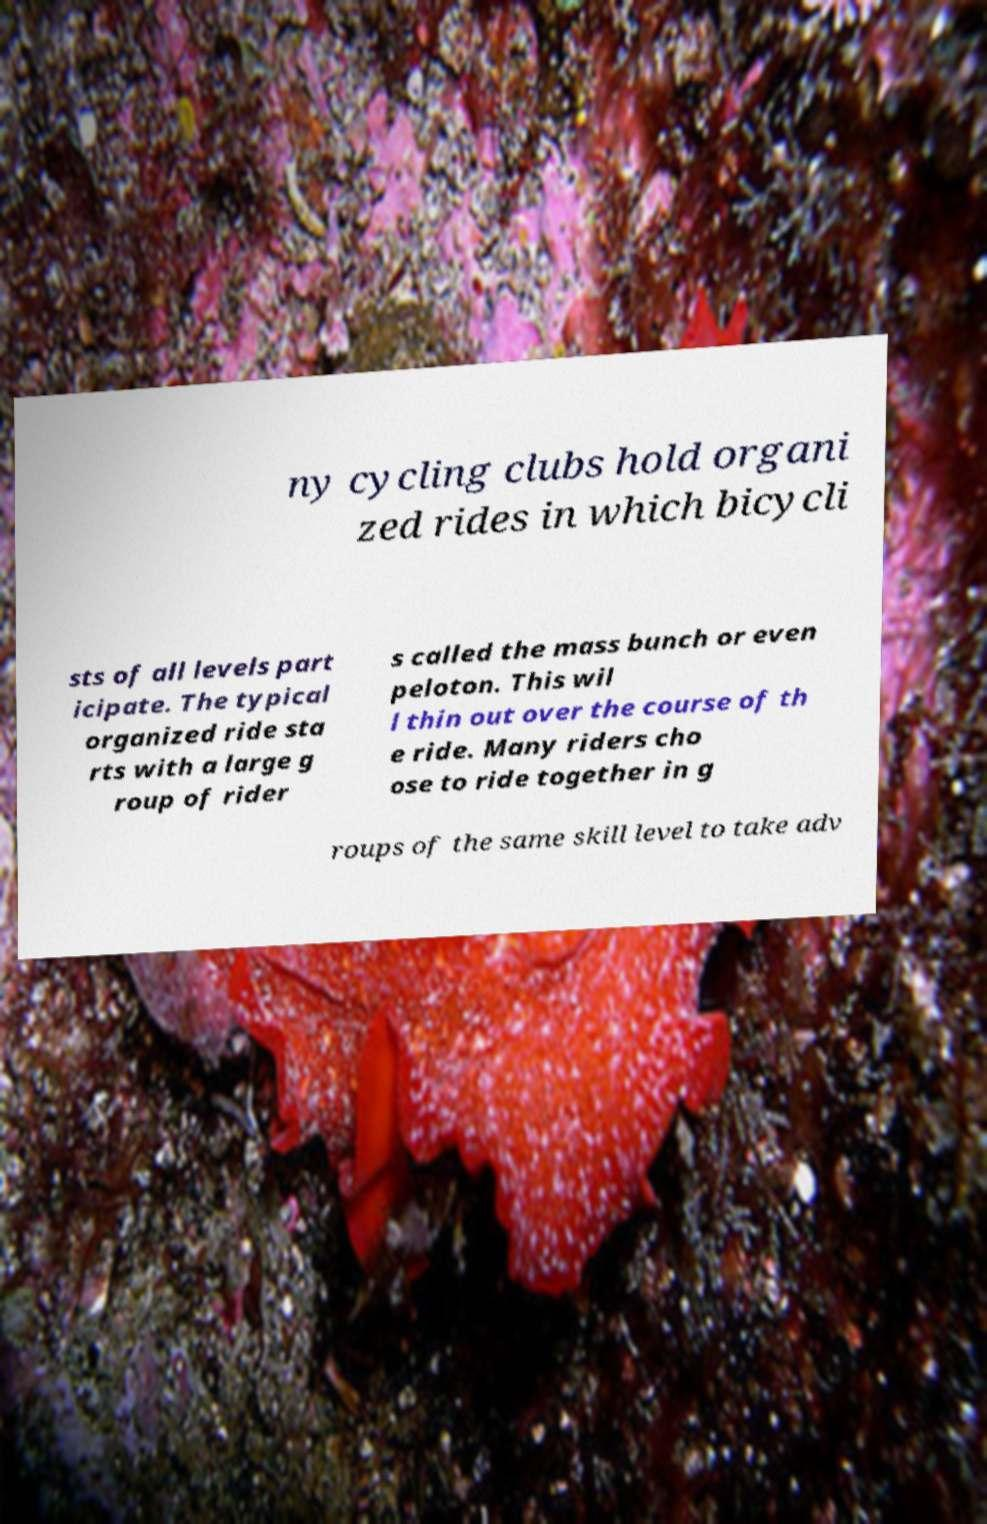What messages or text are displayed in this image? I need them in a readable, typed format. ny cycling clubs hold organi zed rides in which bicycli sts of all levels part icipate. The typical organized ride sta rts with a large g roup of rider s called the mass bunch or even peloton. This wil l thin out over the course of th e ride. Many riders cho ose to ride together in g roups of the same skill level to take adv 